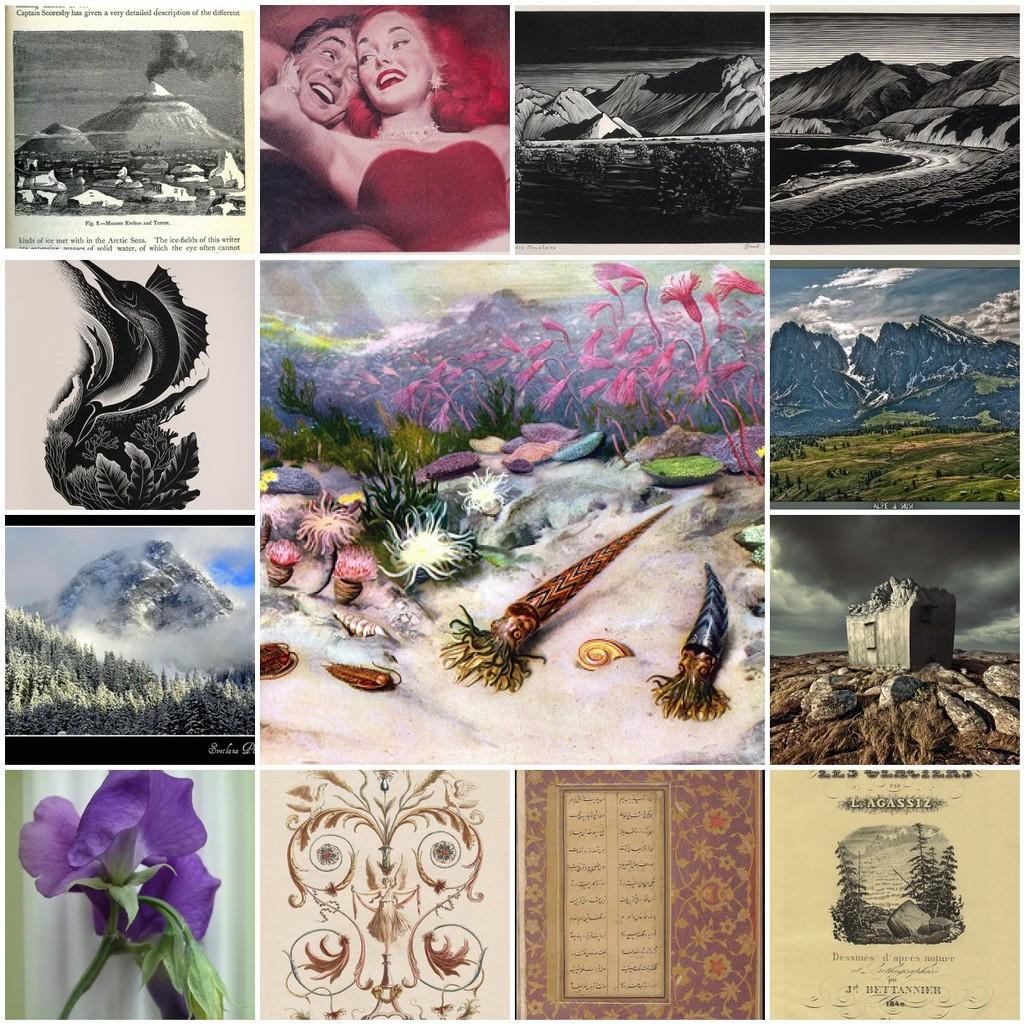How would you summarize this image in a sentence or two? In this image we can see the collage picture. And there are few images like persons, mountains, trees and flowers. 